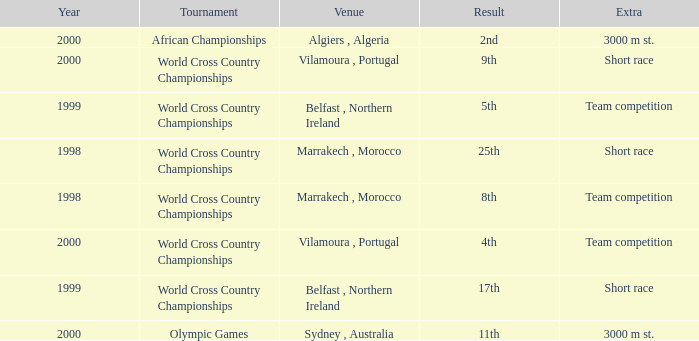Tell me the venue for extra of short race and year less than 1999 Marrakech , Morocco. 